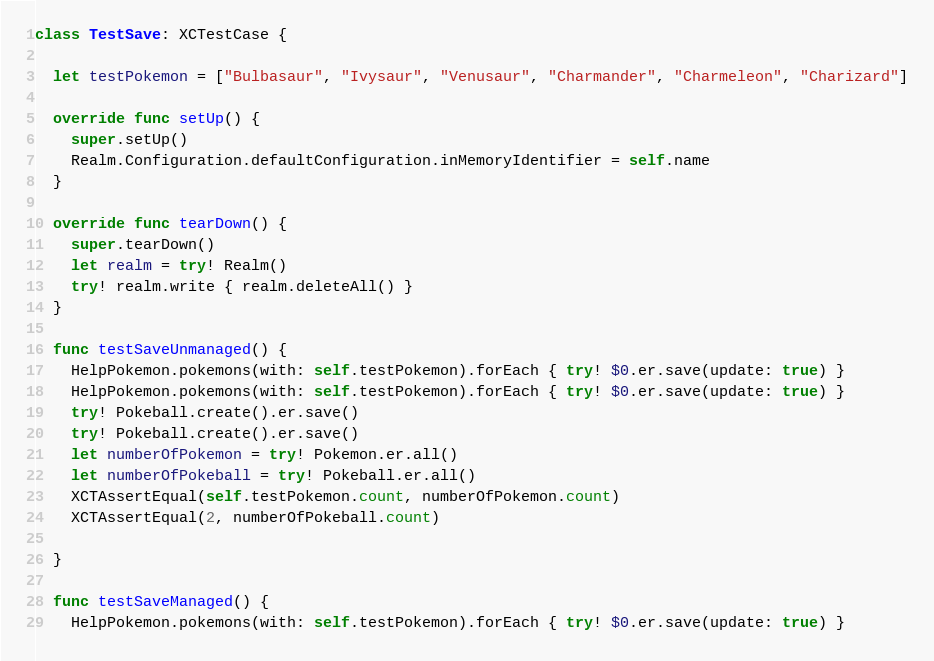Convert code to text. <code><loc_0><loc_0><loc_500><loc_500><_Swift_>class TestSave: XCTestCase {

  let testPokemon = ["Bulbasaur", "Ivysaur", "Venusaur", "Charmander", "Charmeleon", "Charizard"]

  override func setUp() {
    super.setUp()
    Realm.Configuration.defaultConfiguration.inMemoryIdentifier = self.name
  }

  override func tearDown() {
    super.tearDown()
    let realm = try! Realm()
    try! realm.write { realm.deleteAll() }
  }

  func testSaveUnmanaged() {
    HelpPokemon.pokemons(with: self.testPokemon).forEach { try! $0.er.save(update: true) }
    HelpPokemon.pokemons(with: self.testPokemon).forEach { try! $0.er.save(update: true) }
    try! Pokeball.create().er.save()
    try! Pokeball.create().er.save()
    let numberOfPokemon = try! Pokemon.er.all()
    let numberOfPokeball = try! Pokeball.er.all()
    XCTAssertEqual(self.testPokemon.count, numberOfPokemon.count)
    XCTAssertEqual(2, numberOfPokeball.count)

  }

  func testSaveManaged() {
    HelpPokemon.pokemons(with: self.testPokemon).forEach { try! $0.er.save(update: true) }</code> 